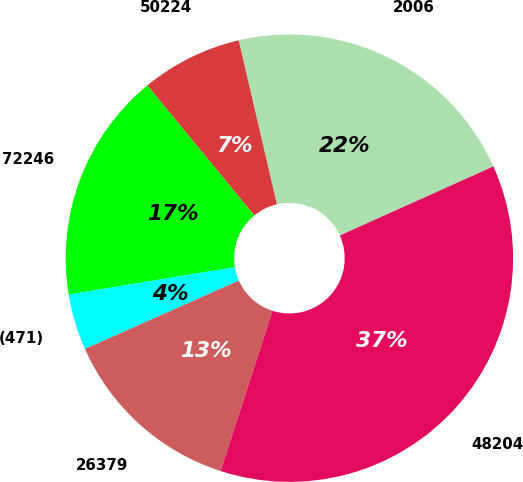Convert chart. <chart><loc_0><loc_0><loc_500><loc_500><pie_chart><fcel>2006<fcel>50224<fcel>72246<fcel>(471)<fcel>26379<fcel>48204<nl><fcel>21.91%<fcel>7.32%<fcel>16.64%<fcel>4.05%<fcel>13.38%<fcel>36.7%<nl></chart> 